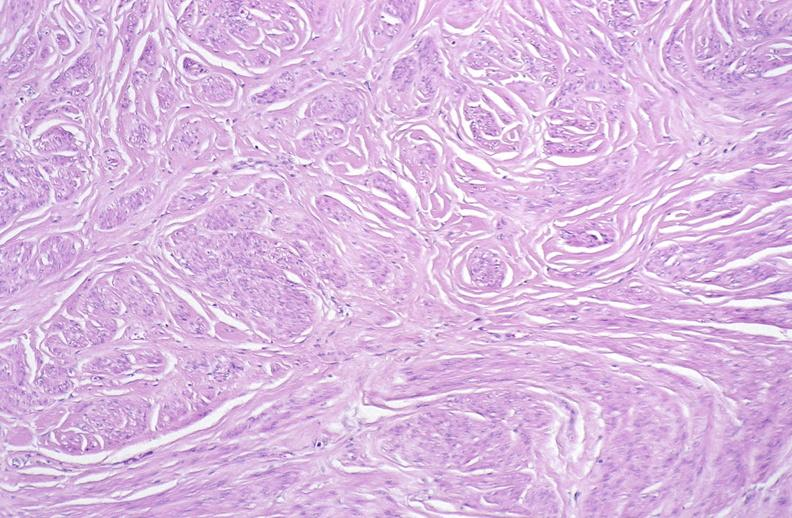what is present?
Answer the question using a single word or phrase. Female reproductive 